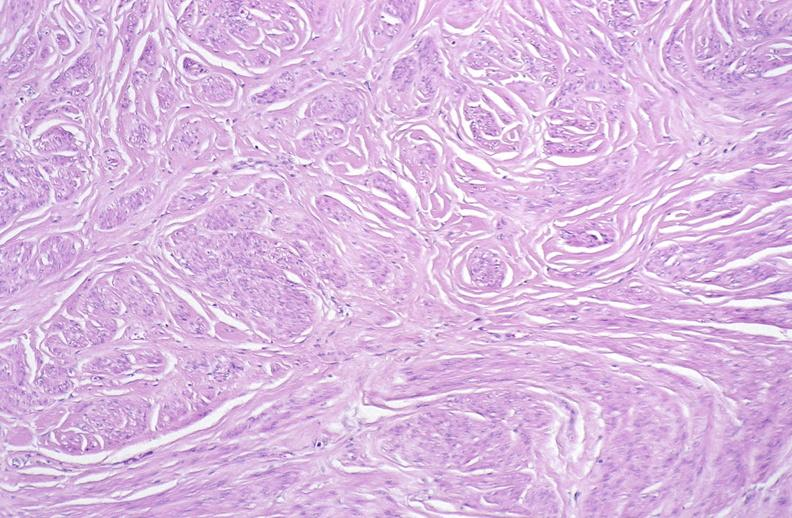what is present?
Answer the question using a single word or phrase. Female reproductive 